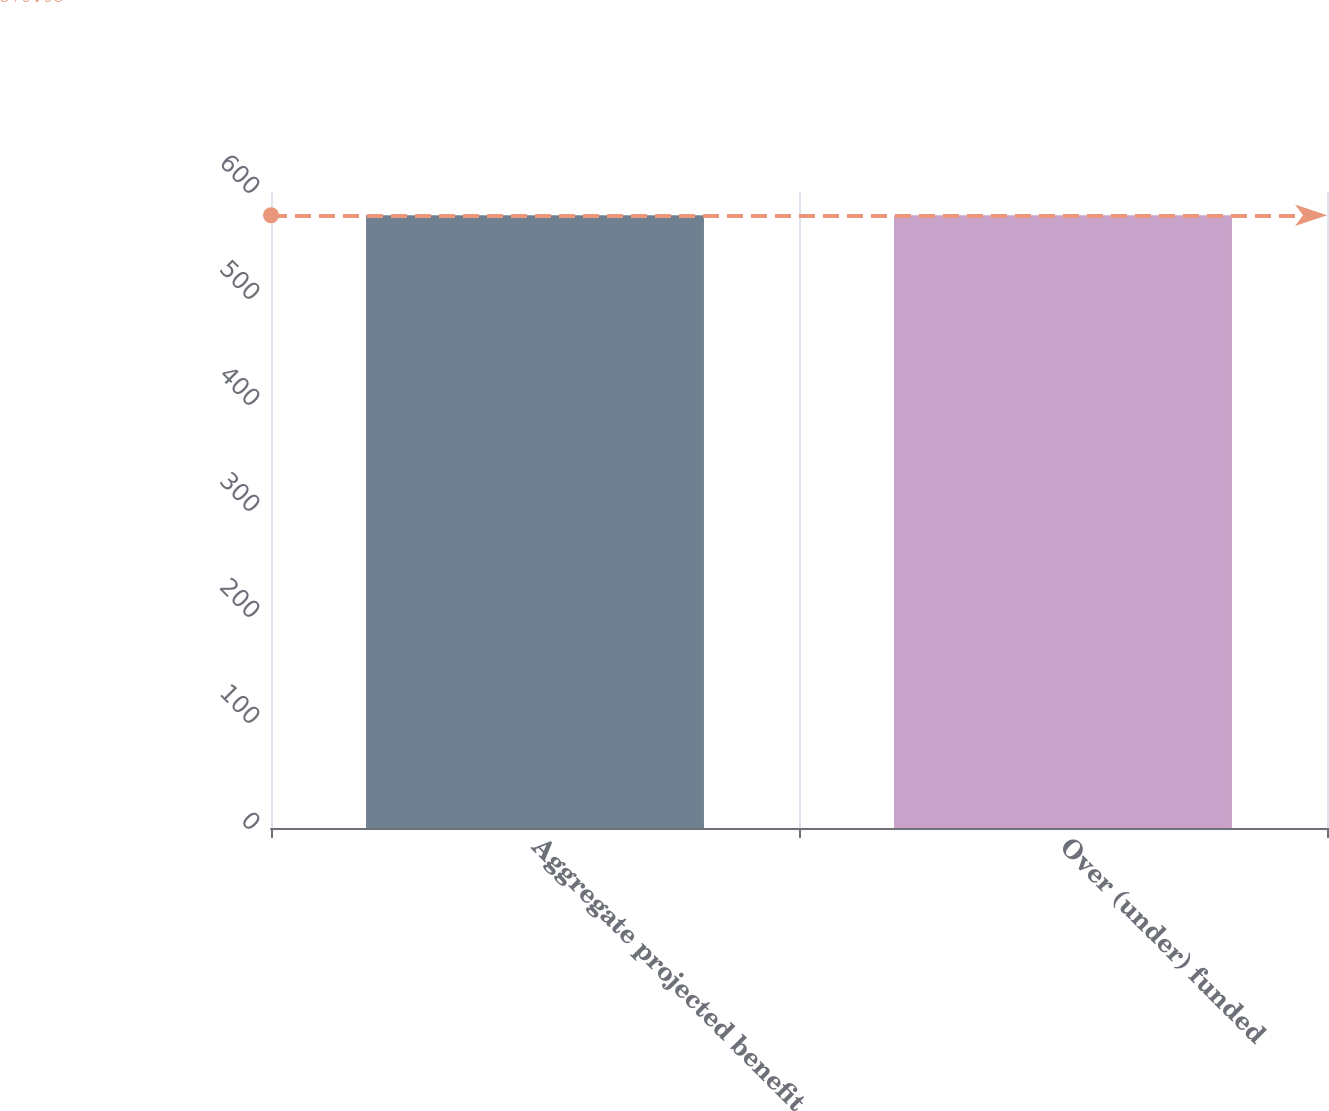Convert chart. <chart><loc_0><loc_0><loc_500><loc_500><bar_chart><fcel>Aggregate projected benefit<fcel>Over (under) funded<nl><fcel>578<fcel>578.1<nl></chart> 